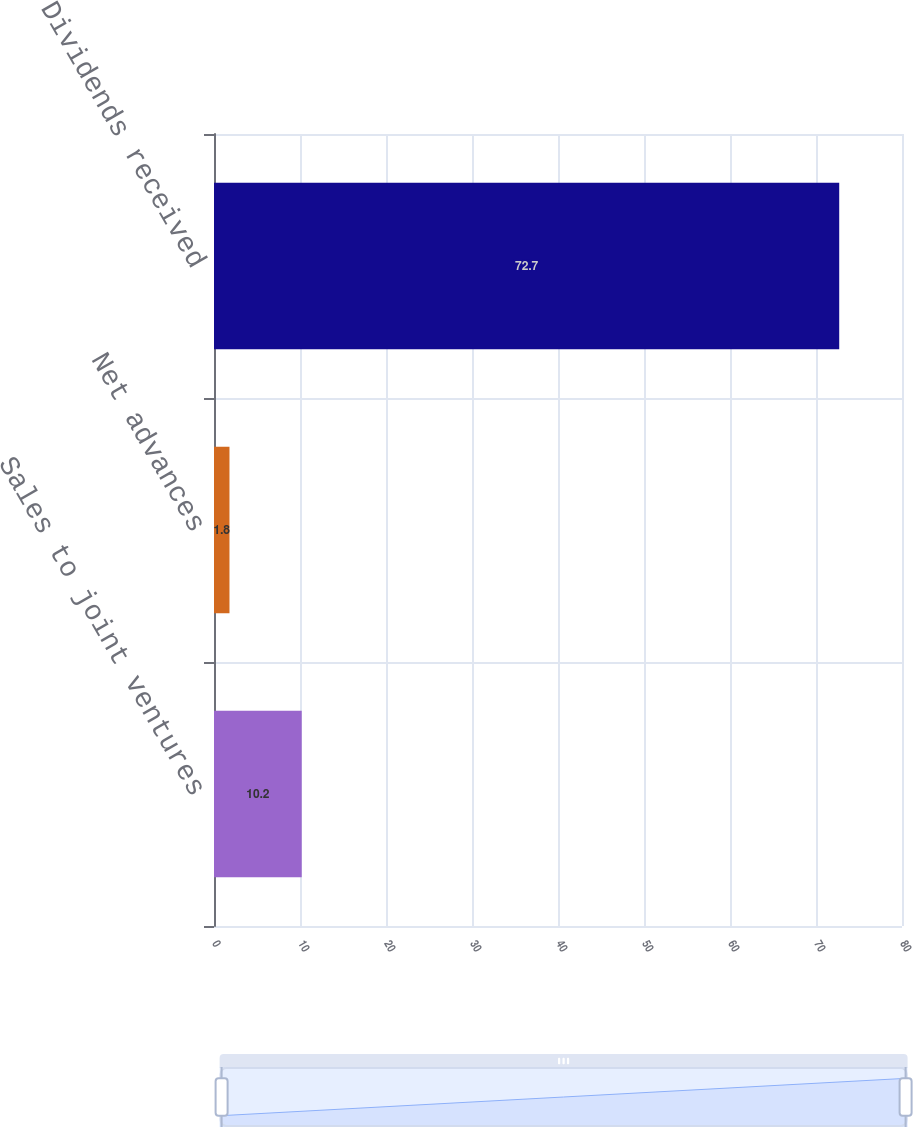Convert chart to OTSL. <chart><loc_0><loc_0><loc_500><loc_500><bar_chart><fcel>Sales to joint ventures<fcel>Net advances<fcel>Dividends received<nl><fcel>10.2<fcel>1.8<fcel>72.7<nl></chart> 